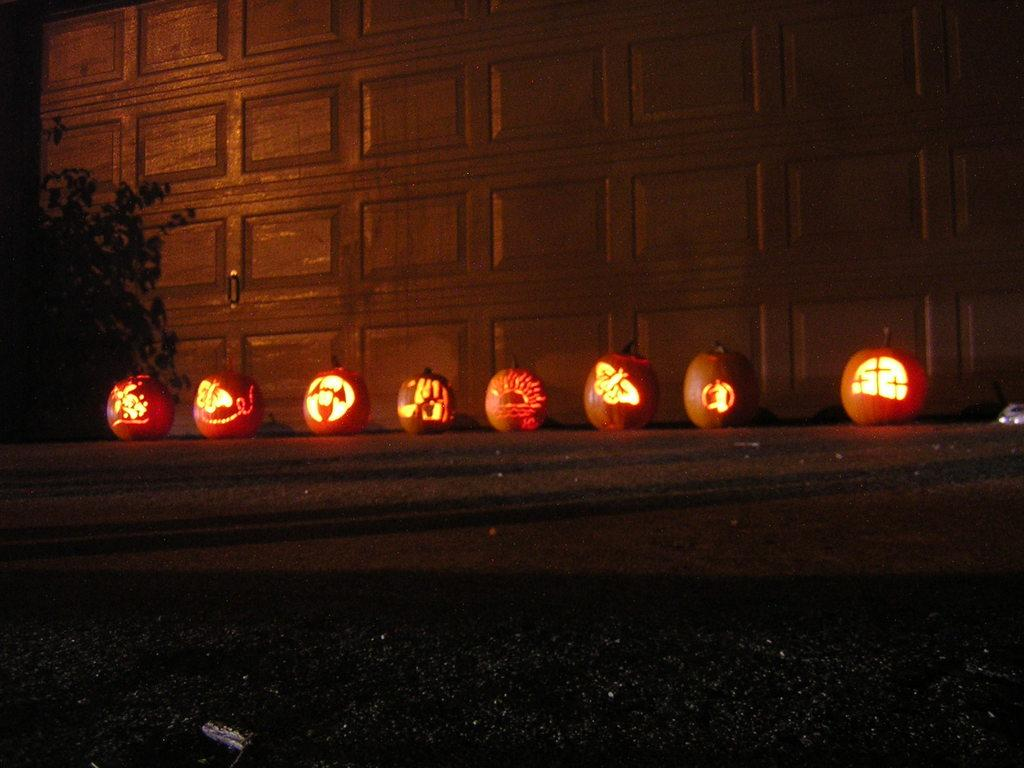What is the main feature of the image? There is a road in the image. What objects are placed along the road? There are pumpkins with lights in the image. What can be seen on the left side of the image? There is a tree on the left side of the image. Can you see a squirrel climbing the tree in the image? There is no squirrel present in the image. What type of reward is being given to the pumpkins in the image? The pumpkins in the image are not receiving any rewards; they have lights attached to them. 